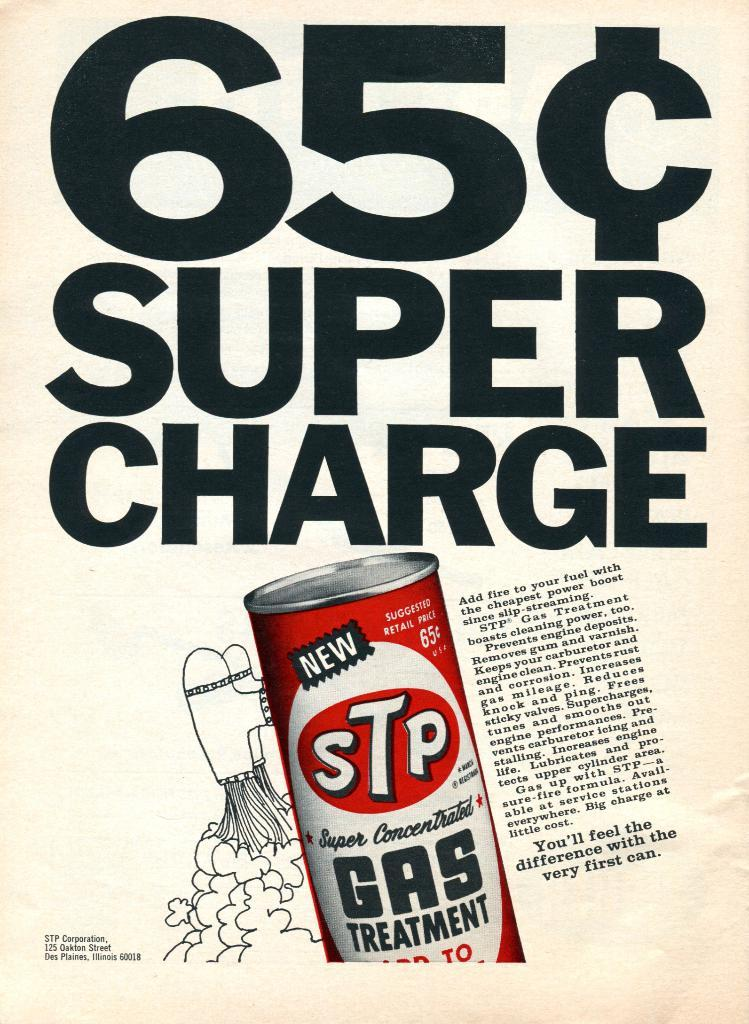<image>
Relay a brief, clear account of the picture shown. A vintage ad for STP gas treatment, showing it for only 65 cents. 